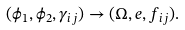<formula> <loc_0><loc_0><loc_500><loc_500>( \phi _ { 1 } , \phi _ { 2 } , \gamma _ { i j } ) \rightarrow ( \Omega , { e } , f _ { i j } ) .</formula> 